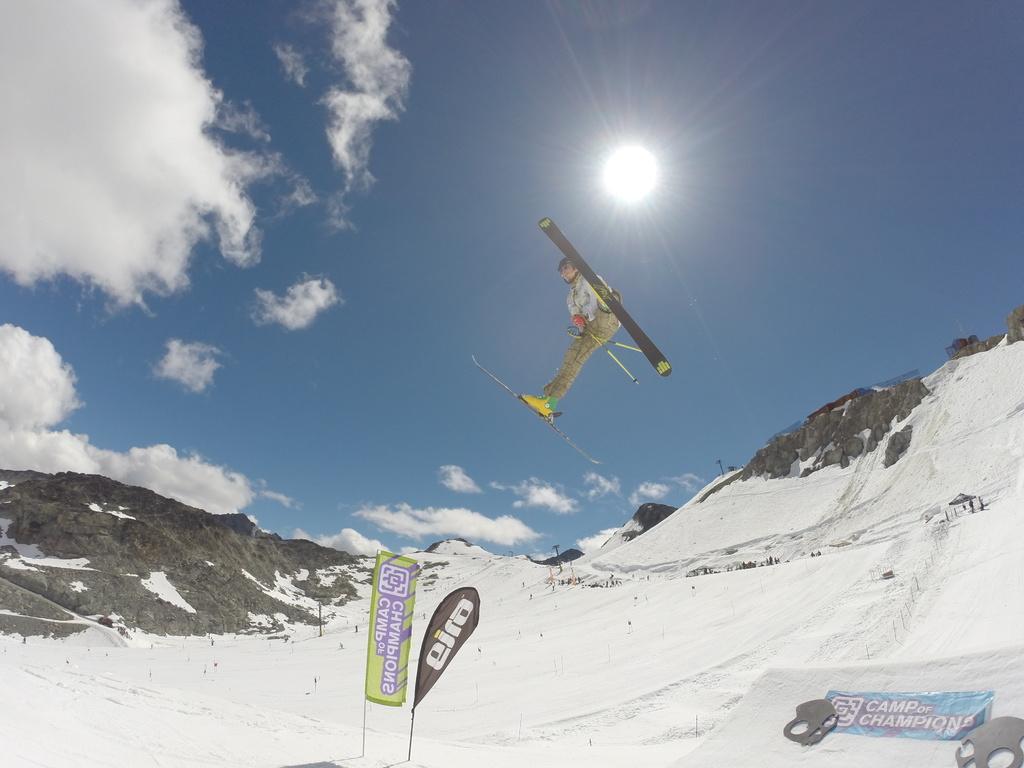How would you summarize this image in a sentence or two? A person is jumping in an air. This person wore skates, this is the snow. At the top it's a sun and there are clouds in this sky. 